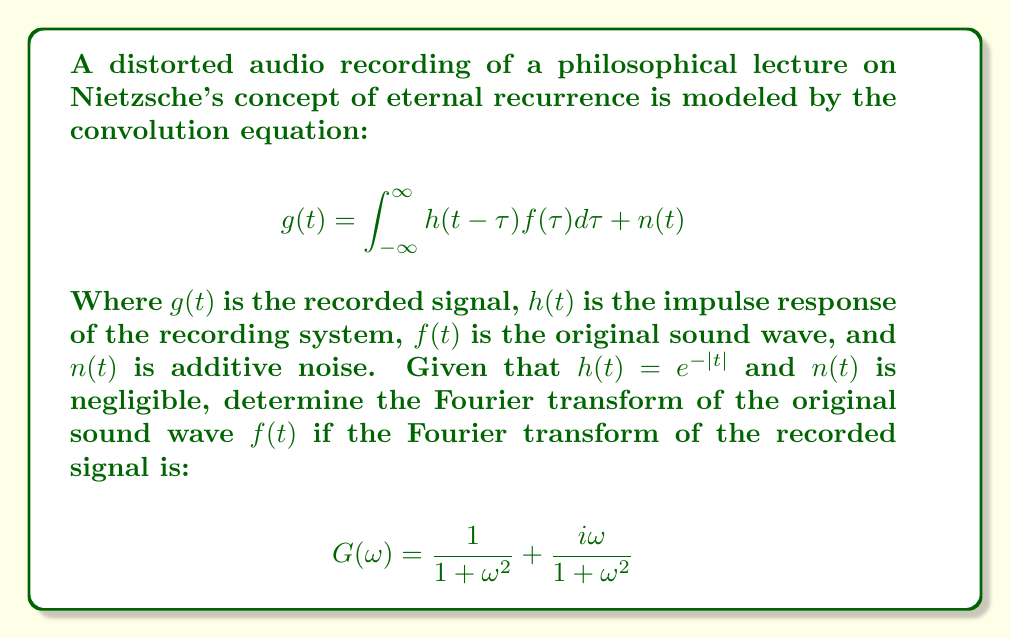Can you solve this math problem? To solve this inverse problem and determine the original sound wave, we'll follow these steps:

1) First, recall that the Fourier transform of a convolution is the product of the Fourier transforms:

   $$G(\omega) = H(\omega)F(\omega) + N(\omega)$$

   Where $G(\omega)$, $H(\omega)$, $F(\omega)$, and $N(\omega)$ are the Fourier transforms of $g(t)$, $h(t)$, $f(t)$, and $n(t)$ respectively.

2) We're given that $h(t) = e^{-|t|}$. The Fourier transform of this function is:

   $$H(\omega) = \frac{2}{1+\omega^2}$$

3) Since $n(t)$ is negligible, we can ignore $N(\omega)$. Our equation becomes:

   $$G(\omega) = H(\omega)F(\omega)$$

4) Substituting the known values:

   $$\frac{1}{1+\omega^2} + \frac{i\omega}{1+\omega^2} = \frac{2}{1+\omega^2}F(\omega)$$

5) To solve for $F(\omega)$, we divide both sides by $H(\omega)$:

   $$F(\omega) = \frac{G(\omega)}{H(\omega)} = \frac{\frac{1}{1+\omega^2} + \frac{i\omega}{1+\omega^2}}{\frac{2}{1+\omega^2}}$$

6) Simplifying:

   $$F(\omega) = \frac{1 + i\omega}{2}$$

This is the Fourier transform of the original sound wave $f(t)$.
Answer: $F(\omega) = \frac{1 + i\omega}{2}$ 